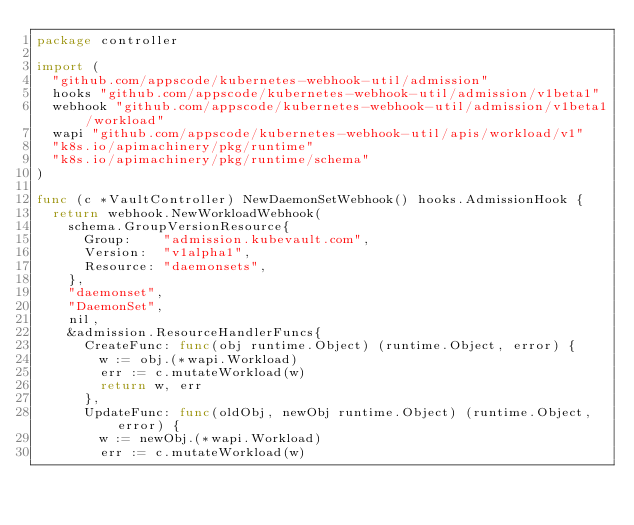Convert code to text. <code><loc_0><loc_0><loc_500><loc_500><_Go_>package controller

import (
	"github.com/appscode/kubernetes-webhook-util/admission"
	hooks "github.com/appscode/kubernetes-webhook-util/admission/v1beta1"
	webhook "github.com/appscode/kubernetes-webhook-util/admission/v1beta1/workload"
	wapi "github.com/appscode/kubernetes-webhook-util/apis/workload/v1"
	"k8s.io/apimachinery/pkg/runtime"
	"k8s.io/apimachinery/pkg/runtime/schema"
)

func (c *VaultController) NewDaemonSetWebhook() hooks.AdmissionHook {
	return webhook.NewWorkloadWebhook(
		schema.GroupVersionResource{
			Group:    "admission.kubevault.com",
			Version:  "v1alpha1",
			Resource: "daemonsets",
		},
		"daemonset",
		"DaemonSet",
		nil,
		&admission.ResourceHandlerFuncs{
			CreateFunc: func(obj runtime.Object) (runtime.Object, error) {
				w := obj.(*wapi.Workload)
				err := c.mutateWorkload(w)
				return w, err
			},
			UpdateFunc: func(oldObj, newObj runtime.Object) (runtime.Object, error) {
				w := newObj.(*wapi.Workload)
				err := c.mutateWorkload(w)</code> 